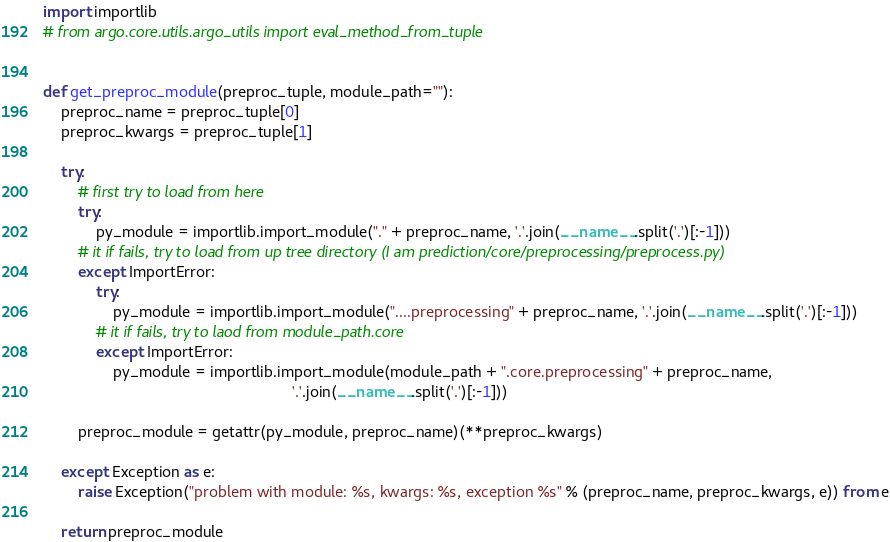Convert code to text. <code><loc_0><loc_0><loc_500><loc_500><_Python_>import importlib
# from argo.core.utils.argo_utils import eval_method_from_tuple


def get_preproc_module(preproc_tuple, module_path=""):
    preproc_name = preproc_tuple[0]
    preproc_kwargs = preproc_tuple[1]

    try:
        # first try to load from here
        try:
            py_module = importlib.import_module("." + preproc_name, '.'.join(__name__.split('.')[:-1]))
        # it if fails, try to load from up tree directory (I am prediction/core/preprocessing/preprocess.py)
        except ImportError:
            try:
                py_module = importlib.import_module("....preprocessing" + preproc_name, '.'.join(__name__.split('.')[:-1]))
            # it if fails, try to laod from module_path.core
            except ImportError:
                py_module = importlib.import_module(module_path + ".core.preprocessing" + preproc_name,
                                                         '.'.join(__name__.split('.')[:-1]))

        preproc_module = getattr(py_module, preproc_name)(**preproc_kwargs)

    except Exception as e:
        raise Exception("problem with module: %s, kwargs: %s, exception %s" % (preproc_name, preproc_kwargs, e)) from e

    return preproc_module
</code> 